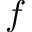<formula> <loc_0><loc_0><loc_500><loc_500>f</formula> 